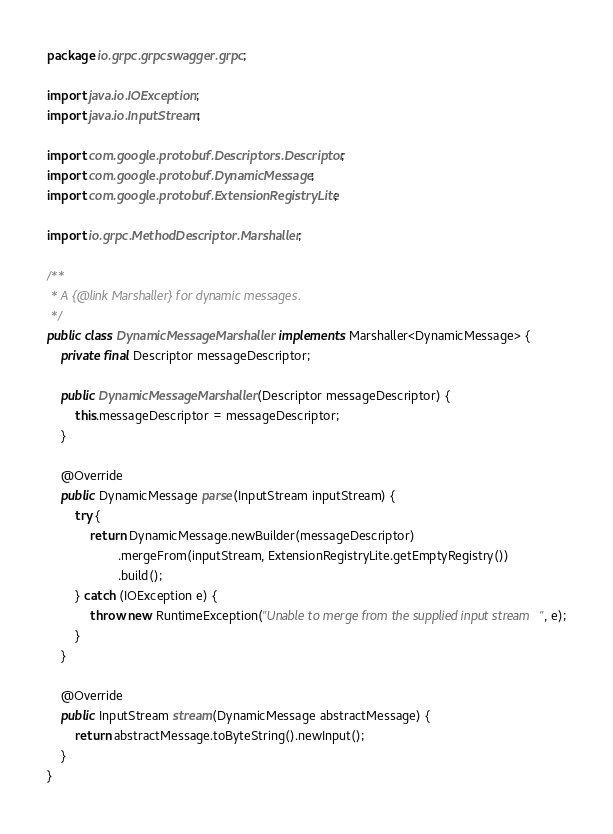<code> <loc_0><loc_0><loc_500><loc_500><_Java_>package io.grpc.grpcswagger.grpc;

import java.io.IOException;
import java.io.InputStream;

import com.google.protobuf.Descriptors.Descriptor;
import com.google.protobuf.DynamicMessage;
import com.google.protobuf.ExtensionRegistryLite;

import io.grpc.MethodDescriptor.Marshaller;

/**
 * A {@link Marshaller} for dynamic messages.
 */
public class DynamicMessageMarshaller implements Marshaller<DynamicMessage> {
    private final Descriptor messageDescriptor;

    public DynamicMessageMarshaller(Descriptor messageDescriptor) {
        this.messageDescriptor = messageDescriptor;
    }

    @Override
    public DynamicMessage parse(InputStream inputStream) {
        try {
            return DynamicMessage.newBuilder(messageDescriptor)
                    .mergeFrom(inputStream, ExtensionRegistryLite.getEmptyRegistry())
                    .build();
        } catch (IOException e) {
            throw new RuntimeException("Unable to merge from the supplied input stream", e);
        }
    }

    @Override
    public InputStream stream(DynamicMessage abstractMessage) {
        return abstractMessage.toByteString().newInput();
    }
}</code> 